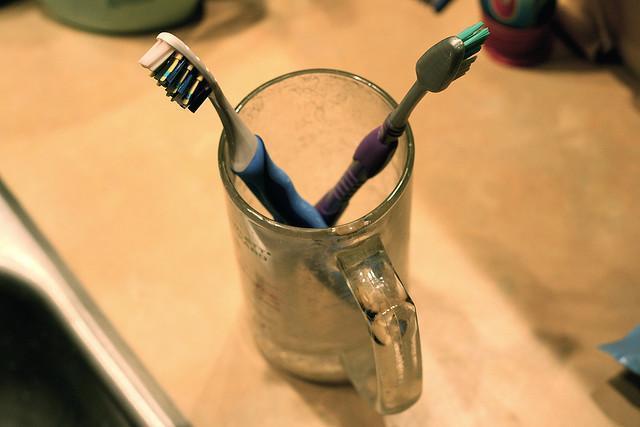How many people use this bathroom?
From the following four choices, select the correct answer to address the question.
Options: Five, four, six, two. Two. 